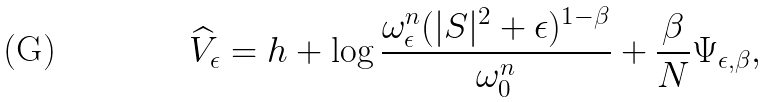<formula> <loc_0><loc_0><loc_500><loc_500>\widehat { V } _ { \epsilon } = h + \log \frac { \omega ^ { n } _ { \epsilon } ( | S | ^ { 2 } + \epsilon ) ^ { 1 - \beta } } { \omega ^ { n } _ { 0 } } + \frac { \beta } { N } \Psi _ { \epsilon , \beta } ,</formula> 